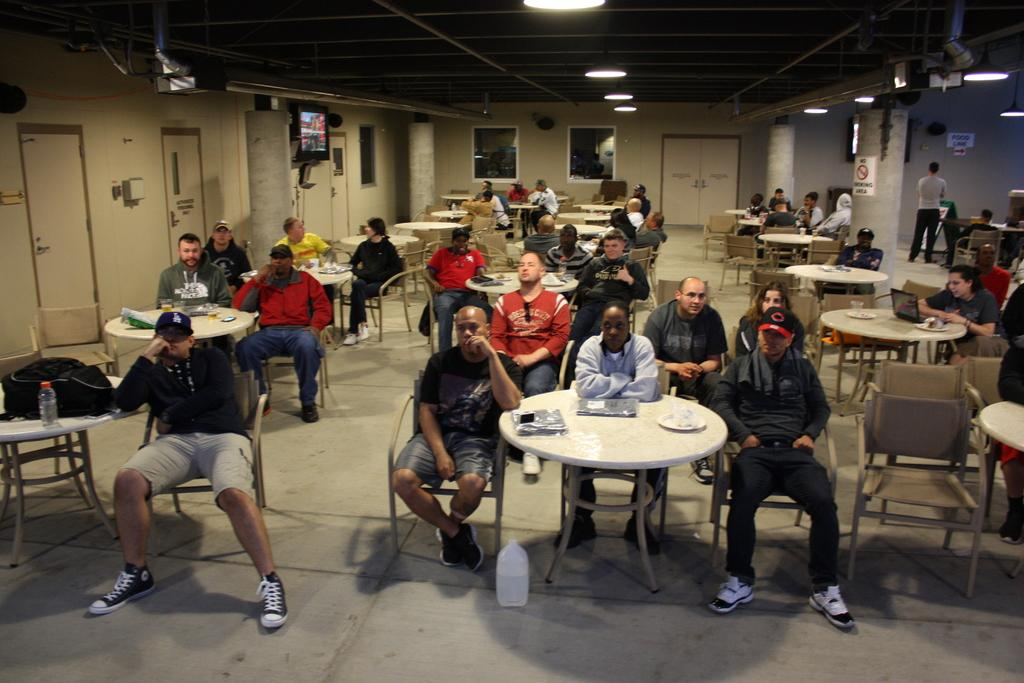How many people are in the image? There is a group of people in the image. What are the people doing in the image? The people are sitting in front of a table. What is on the table in the image? There is a plate and papers on the table. What is to the left of the table in the image? There is a screen to the left of the table. What can be seen in terms of lighting in the image? Some lights are visible in the image. What type of library is visible in the image? There is no library present in the image. 